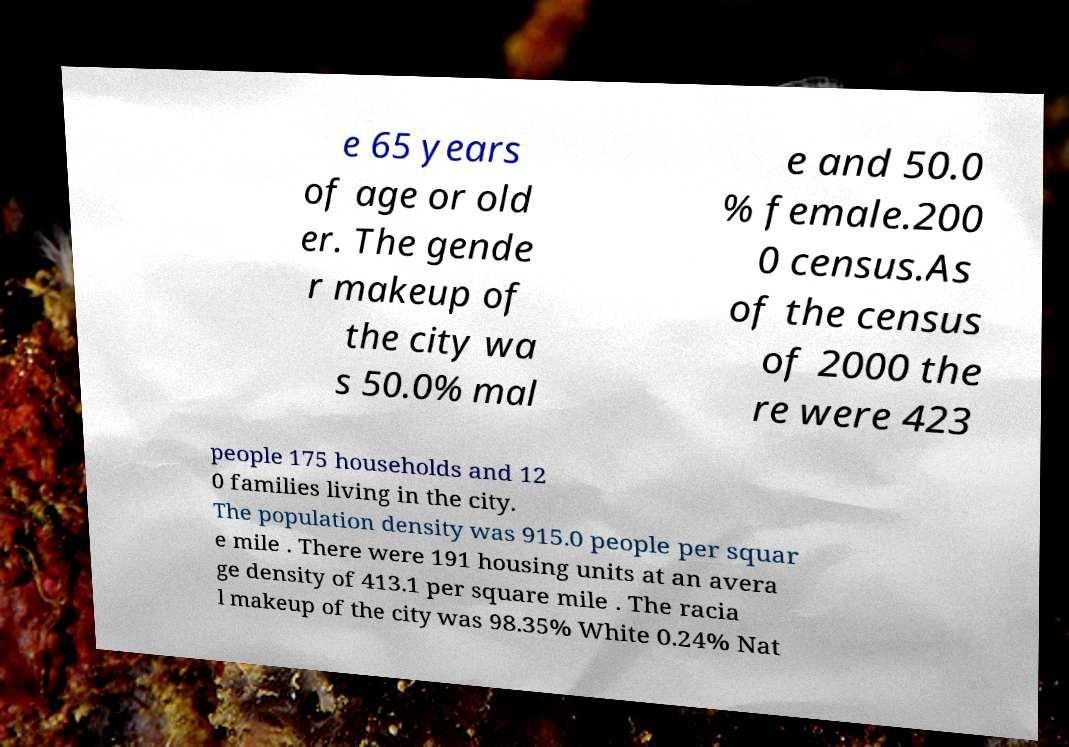What messages or text are displayed in this image? I need them in a readable, typed format. e 65 years of age or old er. The gende r makeup of the city wa s 50.0% mal e and 50.0 % female.200 0 census.As of the census of 2000 the re were 423 people 175 households and 12 0 families living in the city. The population density was 915.0 people per squar e mile . There were 191 housing units at an avera ge density of 413.1 per square mile . The racia l makeup of the city was 98.35% White 0.24% Nat 